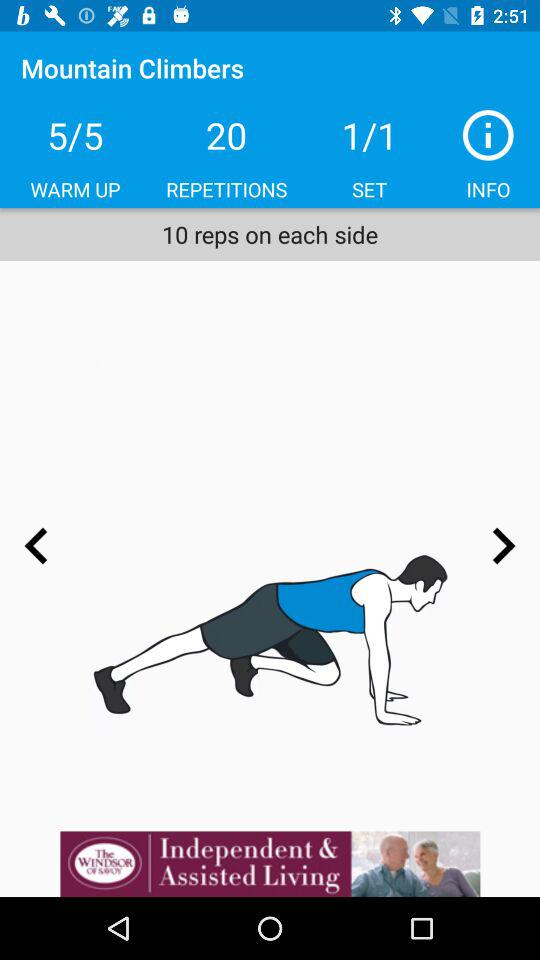How many repetitions are there? There are 20 repetitions. 